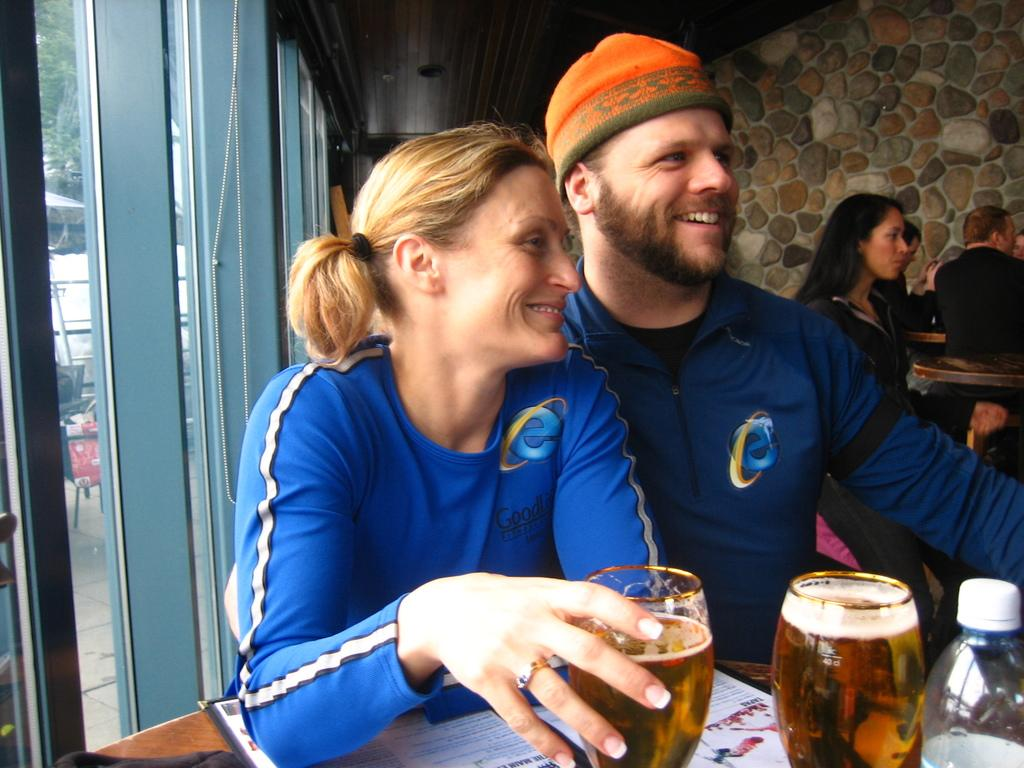What are the people in the image doing? The people in the image are sitting. What objects can be seen on the table in the image? There are glasses, a bottle, and a pamphlet on the table in the image. What is the color of the table? The table is brown in color. What is visible through the window in the image? Trees are visible through the window in the image. Can you see any clovers growing on the table in the image? There are no clovers visible on the table in the image. Is there a lift present in the image? There is no lift present in the image. 